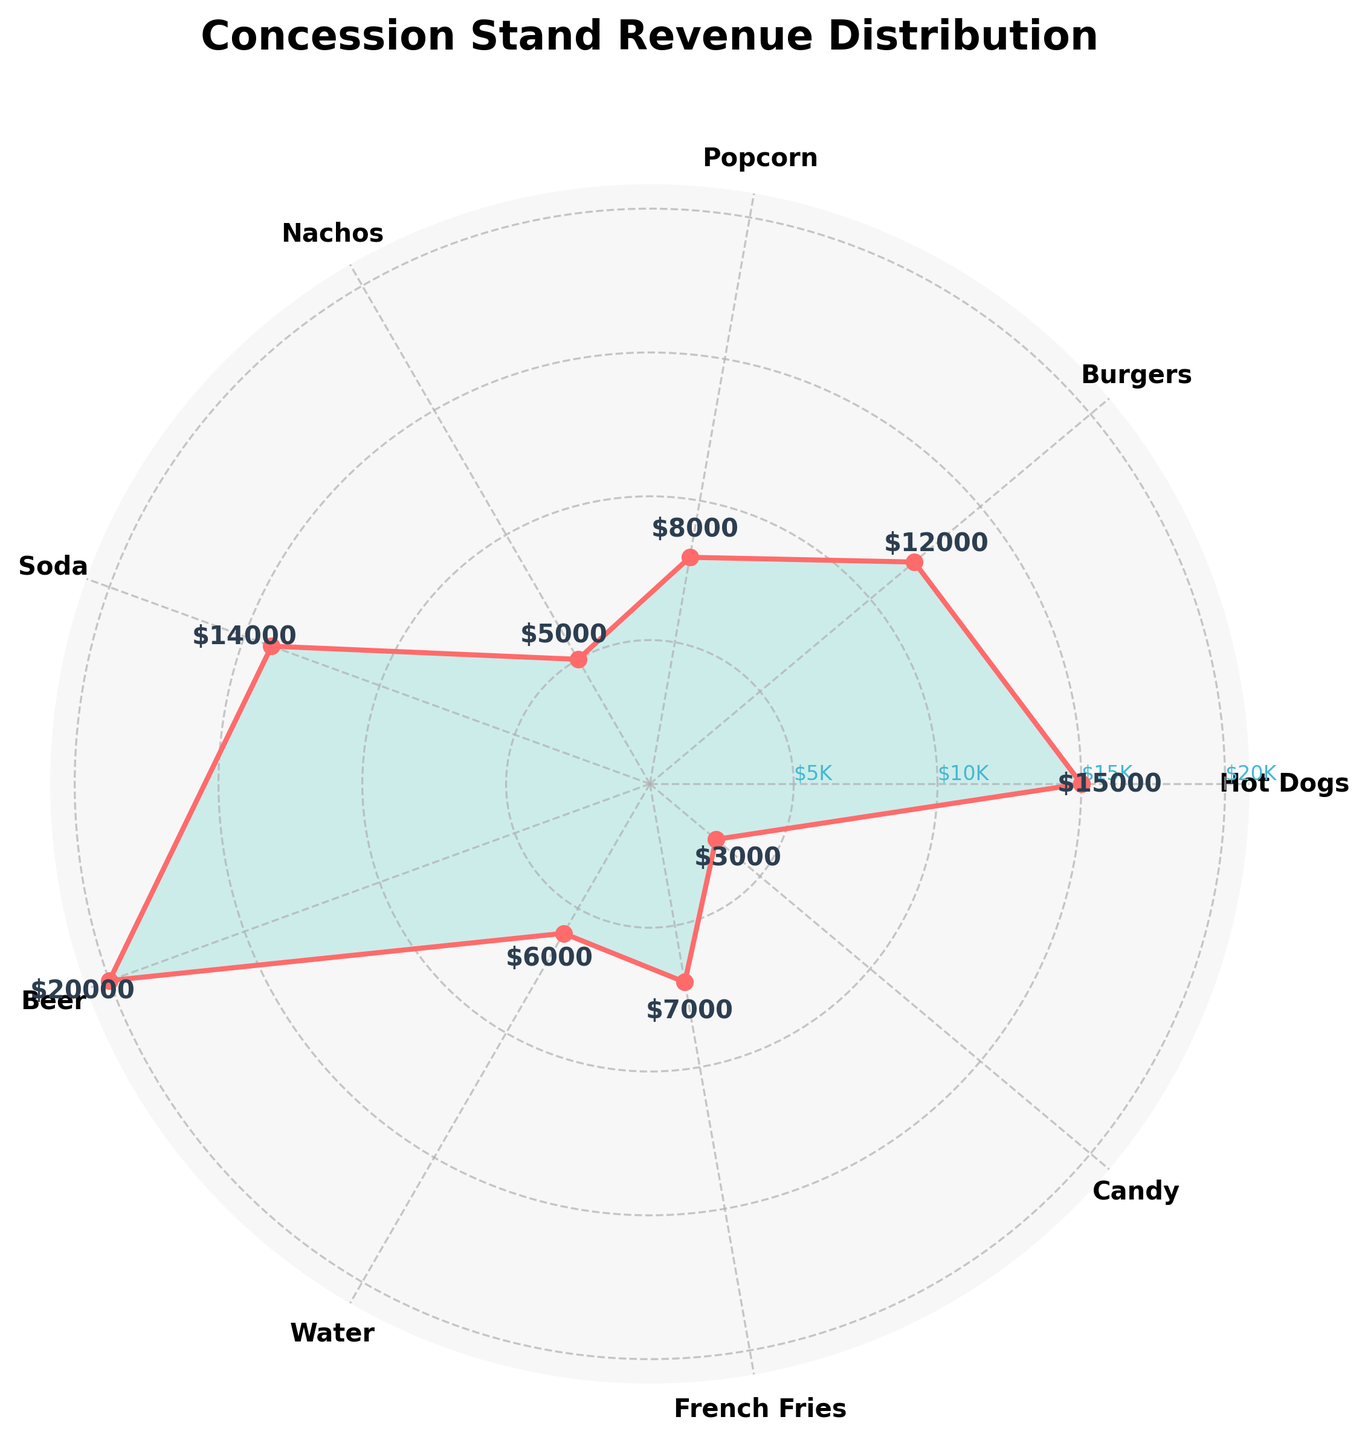What's the title of the chart? The title of the chart is displayed at the top, formatted in a large, bold font. It reads "Concession Stand Revenue Distribution".
Answer: Concession Stand Revenue Distribution How many food and beverage types are represented in the chart? Each segment of the rose chart represents a food or beverage type, and there are ten distinct segments labeled around the perimeter of the chart.
Answer: Ten What is the highest revenue-generating item, and how much does it generate? By comparing the lengths of the radial bars, the item that reaches the highest value at the edge of the chart is Beer, generating $20,000.
Answer: Beer, $20,000 Which two items have the closest revenue values? By assessing the radial bars, Soda and Hot Dogs have revenue values of $14,000 and $15,000, respectively, which are very close.
Answer: Soda and Hot Dogs What's the combined revenue for Hot Dogs and Soda? Locate and sum their individual revenues: $15,000 (Hot Dogs) + $14,000 (Soda) = $29,000.
Answer: $29,000 How much more revenue does Beer generate than Nachos? Identify their values and compute the difference: $20,000 (Beer) - $5,000 (Nachos) = $15,000.
Answer: $15,000 Rank the items with the three lowest revenues. Observe the shortest radial bars and the values they correspond to: Candy ($3,000), Nachos ($5,000), and Water ($6,000).
Answer: Candy, Nachos, Water Are there more food or beverage types represented on the chart? Count and categorize the items. There are 5 beverages (Soda, Beer, Water) and 5 foods (Hot Dogs, Burgers, Popcorn, Nachos, French Fries, Candy).
Answer: Equal, 5 each What is the average revenue generated by the food items? Identify food items' revenues, sum them and divide by their count. ($15,000 + $12,000 + $8,000 + $5,000 + $7,000 + $3,000) / 6 = $8,333.33.
Answer: $8,333.33 What percentage of the total revenue is generated by French Fries? Calculate total revenue and find the percentage for French Fries. Total = $78,000. Percentage = ($7,000 / $78,000) * 100 ≈ 8.97%.
Answer: 8.97% 